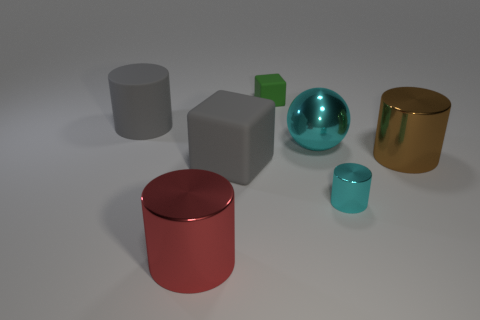Add 2 large cyan metallic things. How many objects exist? 9 Subtract all blocks. How many objects are left? 5 Add 4 brown shiny cylinders. How many brown shiny cylinders are left? 5 Add 5 cyan metallic things. How many cyan metallic things exist? 7 Subtract 1 brown cylinders. How many objects are left? 6 Subtract all large gray cylinders. Subtract all large cyan metallic spheres. How many objects are left? 5 